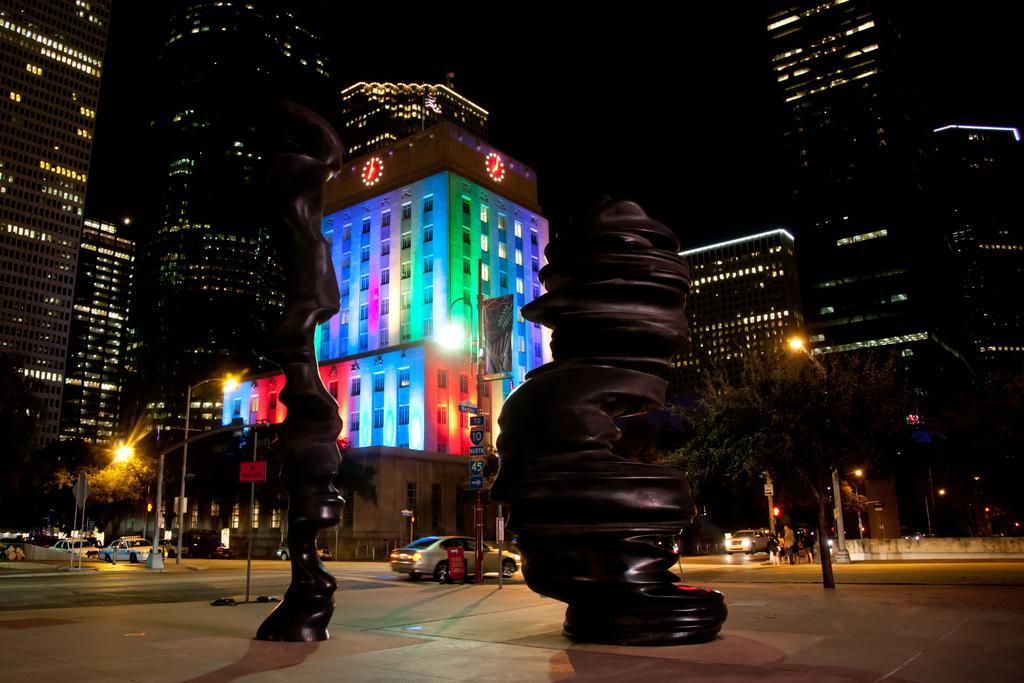Can you describe this image briefly? In this image I can see few black colored objects on the ground and In the background I can see few cars on the ground, few poles, few lights, few trees , few buildings and the dark sky. 